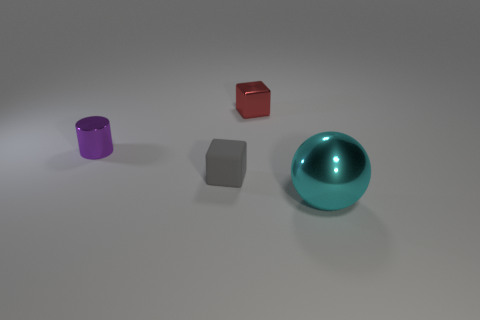Is there anything else that has the same material as the gray block?
Keep it short and to the point. No. What is the shape of the metallic thing that is in front of the small metallic thing that is left of the metallic block?
Provide a succinct answer. Sphere. The metallic thing in front of the shiny thing to the left of the block on the right side of the small gray rubber cube is what shape?
Keep it short and to the point. Sphere. How many other shiny things are the same shape as the tiny red metallic thing?
Make the answer very short. 0. What number of metal things are in front of the tiny block that is in front of the tiny purple shiny cylinder?
Your answer should be compact. 1. What number of rubber things are big cyan spheres or big purple spheres?
Ensure brevity in your answer.  0. Is there a small gray ball made of the same material as the big cyan object?
Your answer should be very brief. No. What number of things are cubes that are in front of the red cube or tiny objects in front of the red object?
Your answer should be very brief. 2. There is a object that is behind the purple metallic cylinder; is it the same color as the cylinder?
Make the answer very short. No. How many other things are there of the same color as the metallic sphere?
Offer a very short reply. 0. 